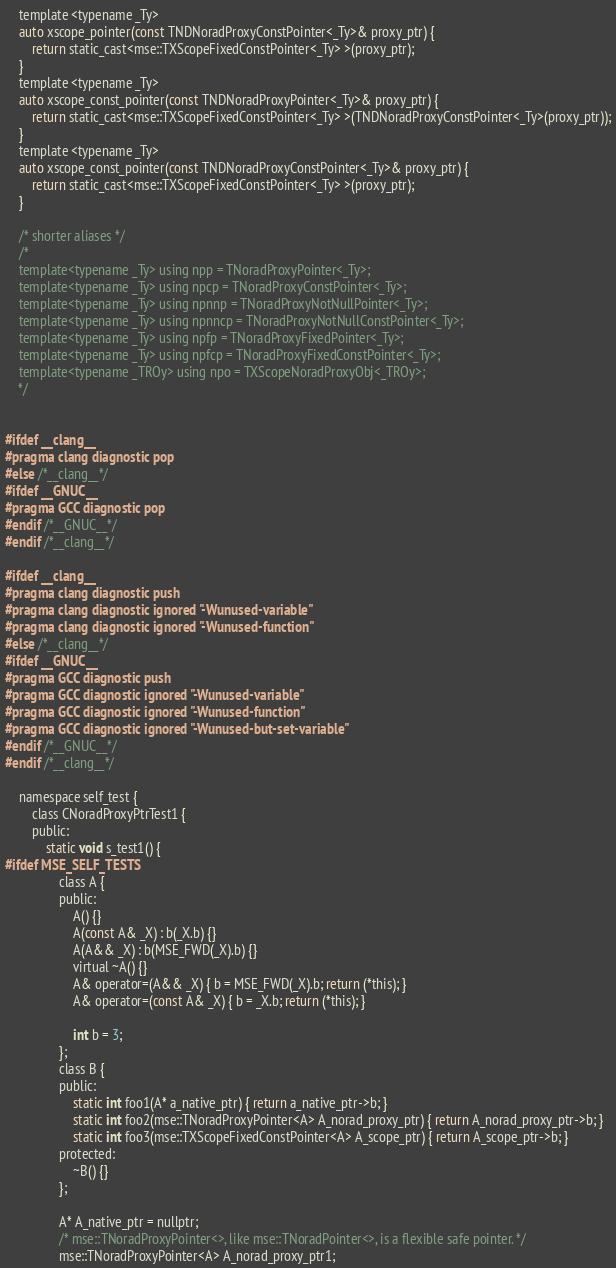<code> <loc_0><loc_0><loc_500><loc_500><_C_>	template <typename _Ty>
	auto xscope_pointer(const TNDNoradProxyConstPointer<_Ty>& proxy_ptr) {
		return static_cast<mse::TXScopeFixedConstPointer<_Ty> >(proxy_ptr);
	}
	template <typename _Ty>
	auto xscope_const_pointer(const TNDNoradProxyPointer<_Ty>& proxy_ptr) {
		return static_cast<mse::TXScopeFixedConstPointer<_Ty> >(TNDNoradProxyConstPointer<_Ty>(proxy_ptr));
	}
	template <typename _Ty>
	auto xscope_const_pointer(const TNDNoradProxyConstPointer<_Ty>& proxy_ptr) {
		return static_cast<mse::TXScopeFixedConstPointer<_Ty> >(proxy_ptr);
	}

	/* shorter aliases */
	/*
	template<typename _Ty> using npp = TNoradProxyPointer<_Ty>;
	template<typename _Ty> using npcp = TNoradProxyConstPointer<_Ty>;
	template<typename _Ty> using npnnp = TNoradProxyNotNullPointer<_Ty>;
	template<typename _Ty> using npnncp = TNoradProxyNotNullConstPointer<_Ty>;
	template<typename _Ty> using npfp = TNoradProxyFixedPointer<_Ty>;
	template<typename _Ty> using npfcp = TNoradProxyFixedConstPointer<_Ty>;
	template<typename _TROy> using npo = TXScopeNoradProxyObj<_TROy>;
	*/


#ifdef __clang__
#pragma clang diagnostic pop
#else /*__clang__*/
#ifdef __GNUC__
#pragma GCC diagnostic pop
#endif /*__GNUC__*/
#endif /*__clang__*/

#ifdef __clang__
#pragma clang diagnostic push
#pragma clang diagnostic ignored "-Wunused-variable"
#pragma clang diagnostic ignored "-Wunused-function"
#else /*__clang__*/
#ifdef __GNUC__
#pragma GCC diagnostic push
#pragma GCC diagnostic ignored "-Wunused-variable"
#pragma GCC diagnostic ignored "-Wunused-function"
#pragma GCC diagnostic ignored "-Wunused-but-set-variable"
#endif /*__GNUC__*/
#endif /*__clang__*/

	namespace self_test {
		class CNoradProxyPtrTest1 {
		public:
			static void s_test1() {
#ifdef MSE_SELF_TESTS
				class A {
				public:
					A() {}
					A(const A& _X) : b(_X.b) {}
					A(A&& _X) : b(MSE_FWD(_X).b) {}
					virtual ~A() {}
					A& operator=(A&& _X) { b = MSE_FWD(_X).b; return (*this); }
					A& operator=(const A& _X) { b = _X.b; return (*this); }

					int b = 3;
				};
				class B {
				public:
					static int foo1(A* a_native_ptr) { return a_native_ptr->b; }
					static int foo2(mse::TNoradProxyPointer<A> A_norad_proxy_ptr) { return A_norad_proxy_ptr->b; }
					static int foo3(mse::TXScopeFixedConstPointer<A> A_scope_ptr) { return A_scope_ptr->b; }
				protected:
					~B() {}
				};

				A* A_native_ptr = nullptr;
				/* mse::TNoradProxyPointer<>, like mse::TNoradPointer<>, is a flexible safe pointer. */
				mse::TNoradProxyPointer<A> A_norad_proxy_ptr1;</code> 